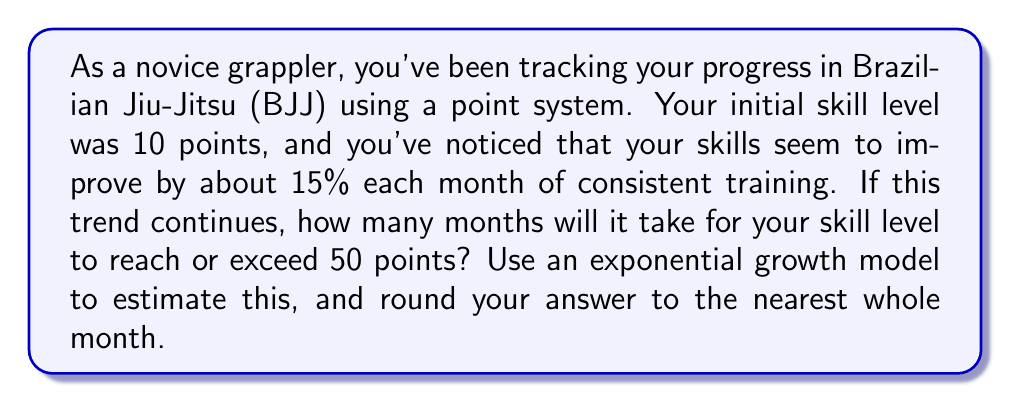What is the answer to this math problem? Let's approach this step-by-step using an exponential growth model:

1) The exponential growth formula is:
   $$A = P(1 + r)^t$$
   where:
   $A$ = final amount
   $P$ = initial amount
   $r$ = growth rate (as a decimal)
   $t$ = time period

2) In this case:
   $P = 10$ (initial skill level)
   $r = 0.15$ (15% growth rate)
   $A = 50$ (target skill level)

3) We need to solve for $t$:
   $$50 = 10(1 + 0.15)^t$$

4) Divide both sides by 10:
   $$5 = (1.15)^t$$

5) Take the natural log of both sides:
   $$\ln(5) = t \cdot \ln(1.15)$$

6) Solve for $t$:
   $$t = \frac{\ln(5)}{\ln(1.15)}$$

7) Calculate:
   $$t = \frac{\ln(5)}{\ln(1.15)} \approx 11.77$$

8) Rounding to the nearest whole month:
   $t \approx 12$ months
Answer: 12 months 